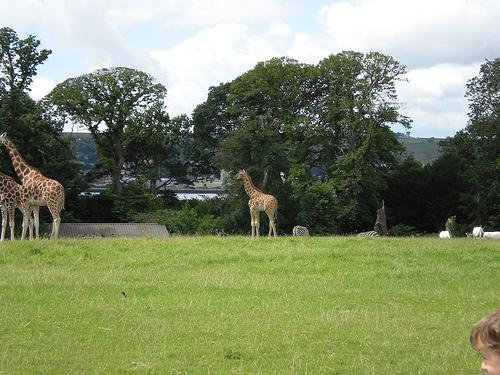Describe the condition and color of the grass in the field. The grass is short, green, and covers an enclosure in the field. What is unique about the giraffe's tail and eyes in the image? One of the giraffes has a long tail and its eye is looking to the left. Count the number of giraffes and zebras in the image. There are four giraffes and two zebras in the image. What kind of structures are found in the background of the image? There are buildings with grey roofs and a small stone wall in the background of the image. How would you describe the sky and the overall weather in the image? The sky is cloudy blue, filled with fluffy white clouds, suggesting a pleasant weather. How many giraffe legs are visible in the photo, and what is their position? There are eight giraffe legs visible in the photo, with four being front legs and the other four being back legs. Identify the two main animals in the image and their colors. There are giraffes and zebras in the image. The giraffes are brown and tan spotted, while the zebras are black and white. Describe the scene involving the young boy in the image. The young boy is watching animals in the field; he has blond hair and is looking into the field where the giraffes and zebras stand. Where are giraffes and zebras standing? Giraffes are standing in a field while zebras are grazing near the trees. Mention the landscape seen behind the field where the animals are grazing. The landscape behind the field consists of a country scenery with dense dark trees and foliage. Mention one unique feature of the giraffe in the image. Long tail Among these options, which animal is standing under a tree? (Options: Giraffe, Zebra, Elephant) Giraffe What is the color of the roof of the building in the background? Grey Which direction is the giraffe looking? To the left What is the dominant color of the giraffe in the image? Brown and tan Look for the flying saucer in the sky next to the fluffy white cloud. No, it's not mentioned in the image. Can you spot fluffy white clouds in the image, and if so where? Yes, in the sky Describe the location of the giraffes in the image. Standing together in a field near a tree Which animal is grazing near the trees in the image? A black and white zebra Find which part of the giraffe is the closest to the kid. The leg of the giraffe What is the hair color of the kid in the image? Brown Count the number of giraffes in the field in the image. Three giraffes Determine the color of the zebras in the image. Black and white Which part of the giraffe is eating from a tree? The head of the giraffe What is the scenery described in the image's background? Country landscape with dense dark trees and cloudy blue skies Identify the location of the zebra in the field. Grazing near the trees What color is the field in the image? Green Locate the head of the little kid in the image. Near the top-right corner of the image Identify the interaction between the boy and the animals. The boy is watching the animals on the field Are there any trees in the image? If so, describe their location. Yes, behind the green field and near the grazing zebras 